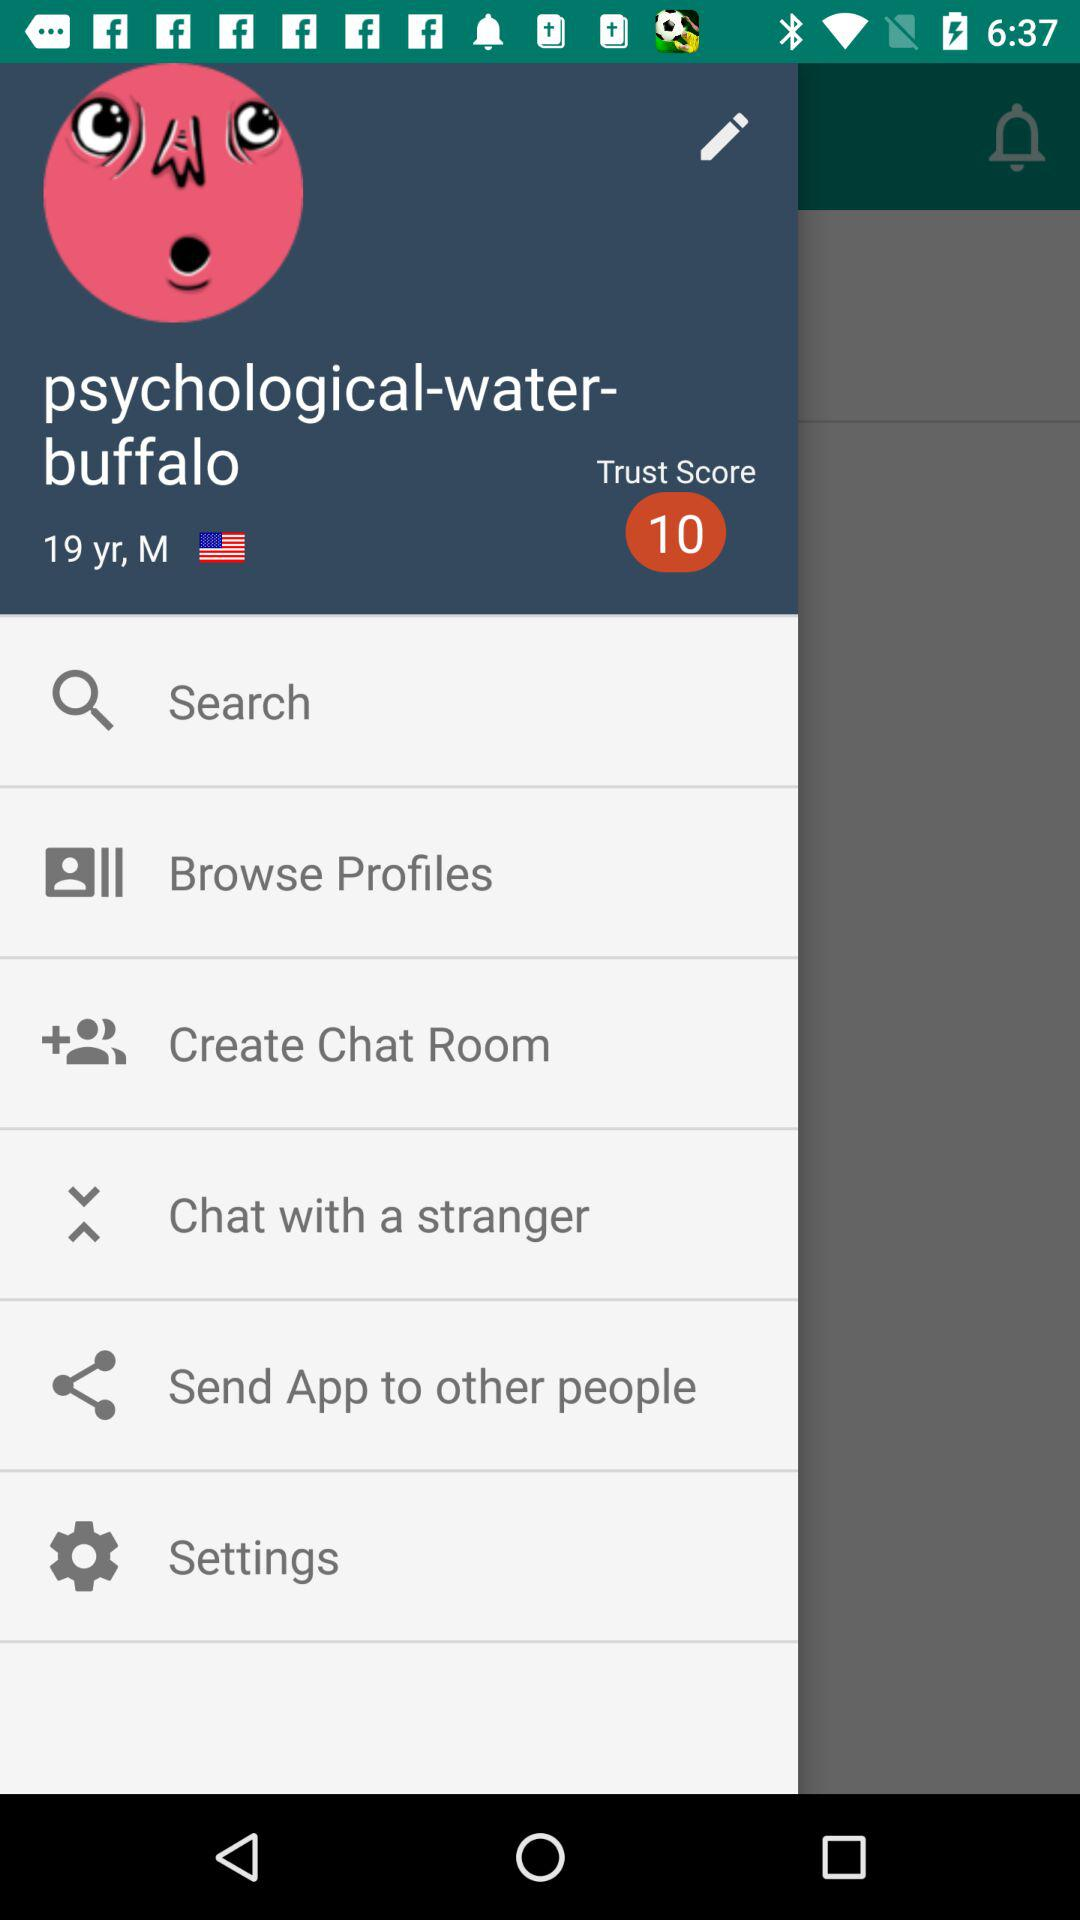What is the user's profile name? The user's profile name is "psychological-water-buffalo". 